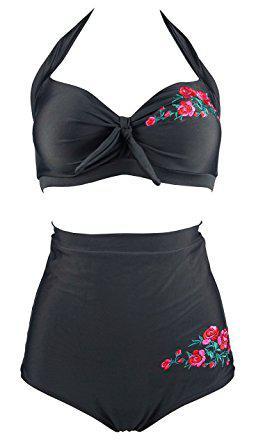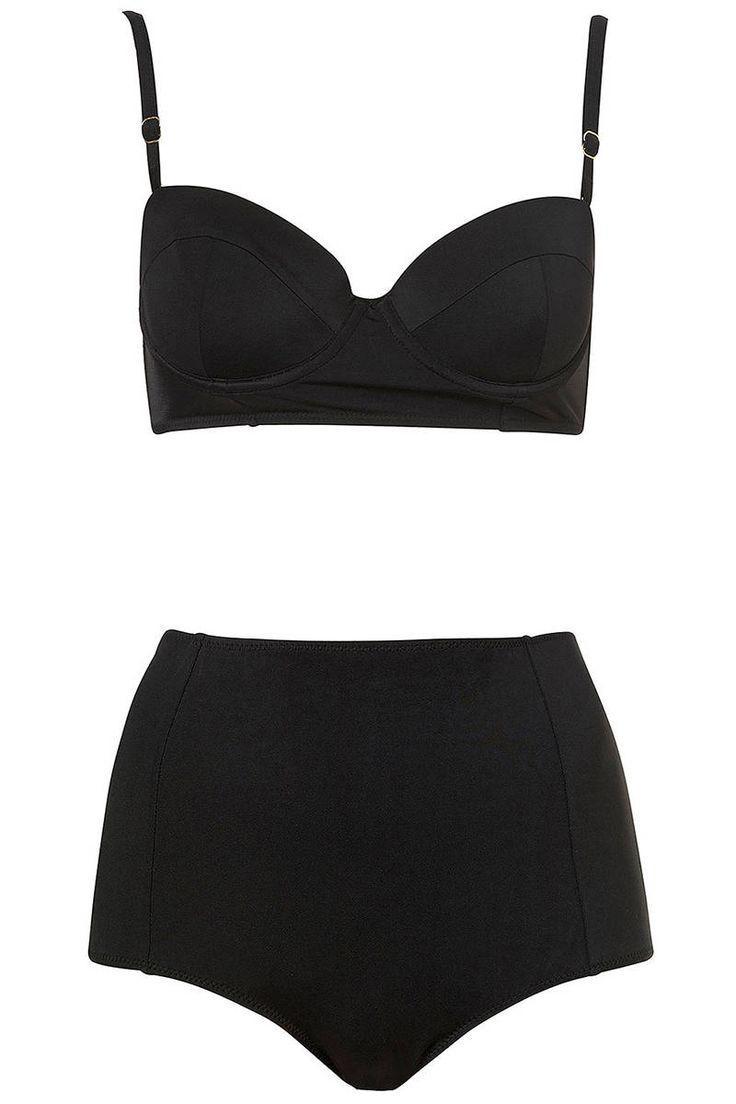The first image is the image on the left, the second image is the image on the right. Considering the images on both sides, is "the bathing suit in one of the images features a tie on bikini top." valid? Answer yes or no. Yes. 